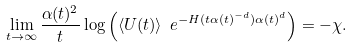<formula> <loc_0><loc_0><loc_500><loc_500>\lim _ { t \to \infty } \frac { \alpha ( t ) ^ { 2 } } t \log \left ( \langle U ( t ) \rangle \ e ^ { - H ( t \alpha ( t ) ^ { - d } ) \alpha ( t ) ^ { d } } \right ) = - \chi .</formula> 